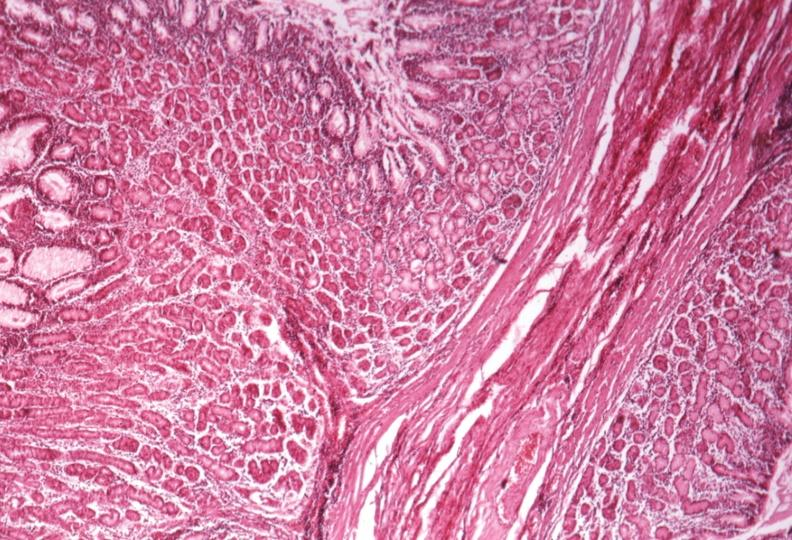s serous cystadenoma present?
Answer the question using a single word or phrase. No 